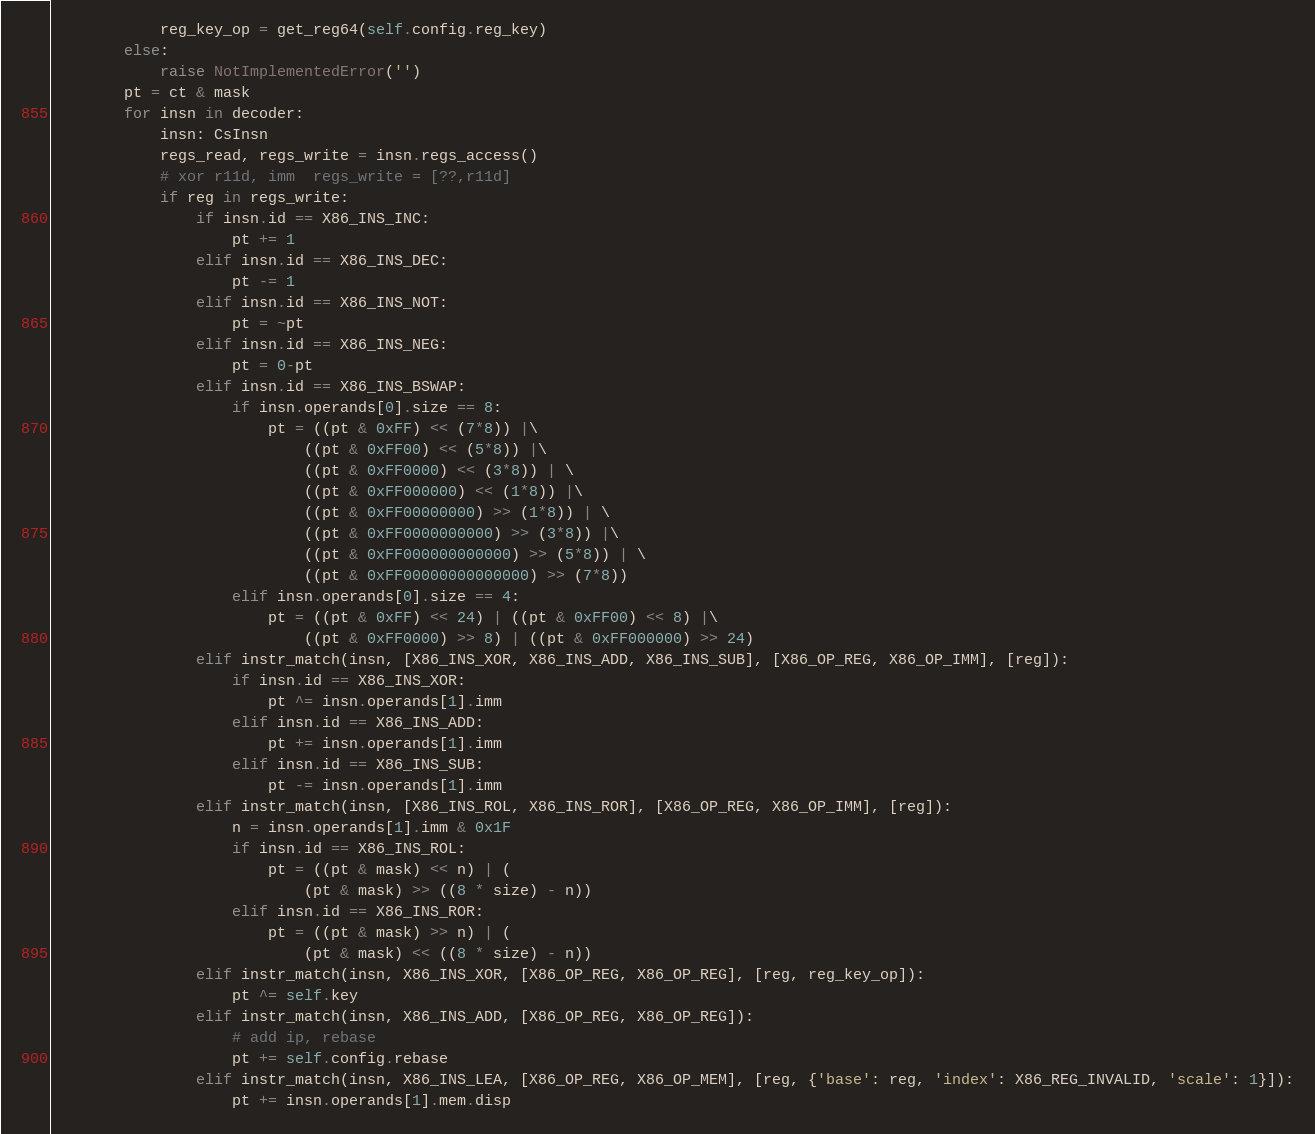<code> <loc_0><loc_0><loc_500><loc_500><_Python_>            reg_key_op = get_reg64(self.config.reg_key)
        else:
            raise NotImplementedError('')
        pt = ct & mask
        for insn in decoder:
            insn: CsInsn
            regs_read, regs_write = insn.regs_access()
            # xor r11d, imm  regs_write = [??,r11d]
            if reg in regs_write:
                if insn.id == X86_INS_INC:
                    pt += 1
                elif insn.id == X86_INS_DEC:
                    pt -= 1
                elif insn.id == X86_INS_NOT:
                    pt = ~pt
                elif insn.id == X86_INS_NEG:
                    pt = 0-pt
                elif insn.id == X86_INS_BSWAP:
                    if insn.operands[0].size == 8:
                        pt = ((pt & 0xFF) << (7*8)) |\
                            ((pt & 0xFF00) << (5*8)) |\
                            ((pt & 0xFF0000) << (3*8)) | \
                            ((pt & 0xFF000000) << (1*8)) |\
                            ((pt & 0xFF00000000) >> (1*8)) | \
                            ((pt & 0xFF0000000000) >> (3*8)) |\
                            ((pt & 0xFF000000000000) >> (5*8)) | \
                            ((pt & 0xFF00000000000000) >> (7*8))
                    elif insn.operands[0].size == 4:
                        pt = ((pt & 0xFF) << 24) | ((pt & 0xFF00) << 8) |\
                            ((pt & 0xFF0000) >> 8) | ((pt & 0xFF000000) >> 24)
                elif instr_match(insn, [X86_INS_XOR, X86_INS_ADD, X86_INS_SUB], [X86_OP_REG, X86_OP_IMM], [reg]):
                    if insn.id == X86_INS_XOR:
                        pt ^= insn.operands[1].imm
                    elif insn.id == X86_INS_ADD:
                        pt += insn.operands[1].imm
                    elif insn.id == X86_INS_SUB:
                        pt -= insn.operands[1].imm
                elif instr_match(insn, [X86_INS_ROL, X86_INS_ROR], [X86_OP_REG, X86_OP_IMM], [reg]):
                    n = insn.operands[1].imm & 0x1F
                    if insn.id == X86_INS_ROL:
                        pt = ((pt & mask) << n) | (
                            (pt & mask) >> ((8 * size) - n))
                    elif insn.id == X86_INS_ROR:
                        pt = ((pt & mask) >> n) | (
                            (pt & mask) << ((8 * size) - n))
                elif instr_match(insn, X86_INS_XOR, [X86_OP_REG, X86_OP_REG], [reg, reg_key_op]):
                    pt ^= self.key
                elif instr_match(insn, X86_INS_ADD, [X86_OP_REG, X86_OP_REG]):
                    # add ip, rebase
                    pt += self.config.rebase
                elif instr_match(insn, X86_INS_LEA, [X86_OP_REG, X86_OP_MEM], [reg, {'base': reg, 'index': X86_REG_INVALID, 'scale': 1}]):
                    pt += insn.operands[1].mem.disp</code> 